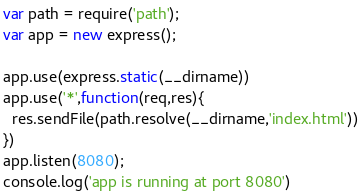<code> <loc_0><loc_0><loc_500><loc_500><_JavaScript_>var path = require('path');
var app = new express();

app.use(express.static(__dirname))
app.use('*',function(req,res){
  res.sendFile(path.resolve(__dirname,'index.html'))
})
app.listen(8080);
console.log('app is running at port 8080')
</code> 